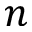<formula> <loc_0><loc_0><loc_500><loc_500>n</formula> 